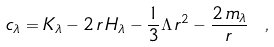<formula> <loc_0><loc_0><loc_500><loc_500>c _ { \lambda } = K _ { \lambda } - 2 \, r \, H _ { \lambda } - \frac { 1 } { 3 } \Lambda \, r ^ { 2 } - \frac { 2 \, m _ { \lambda } } { r } \ ,</formula> 